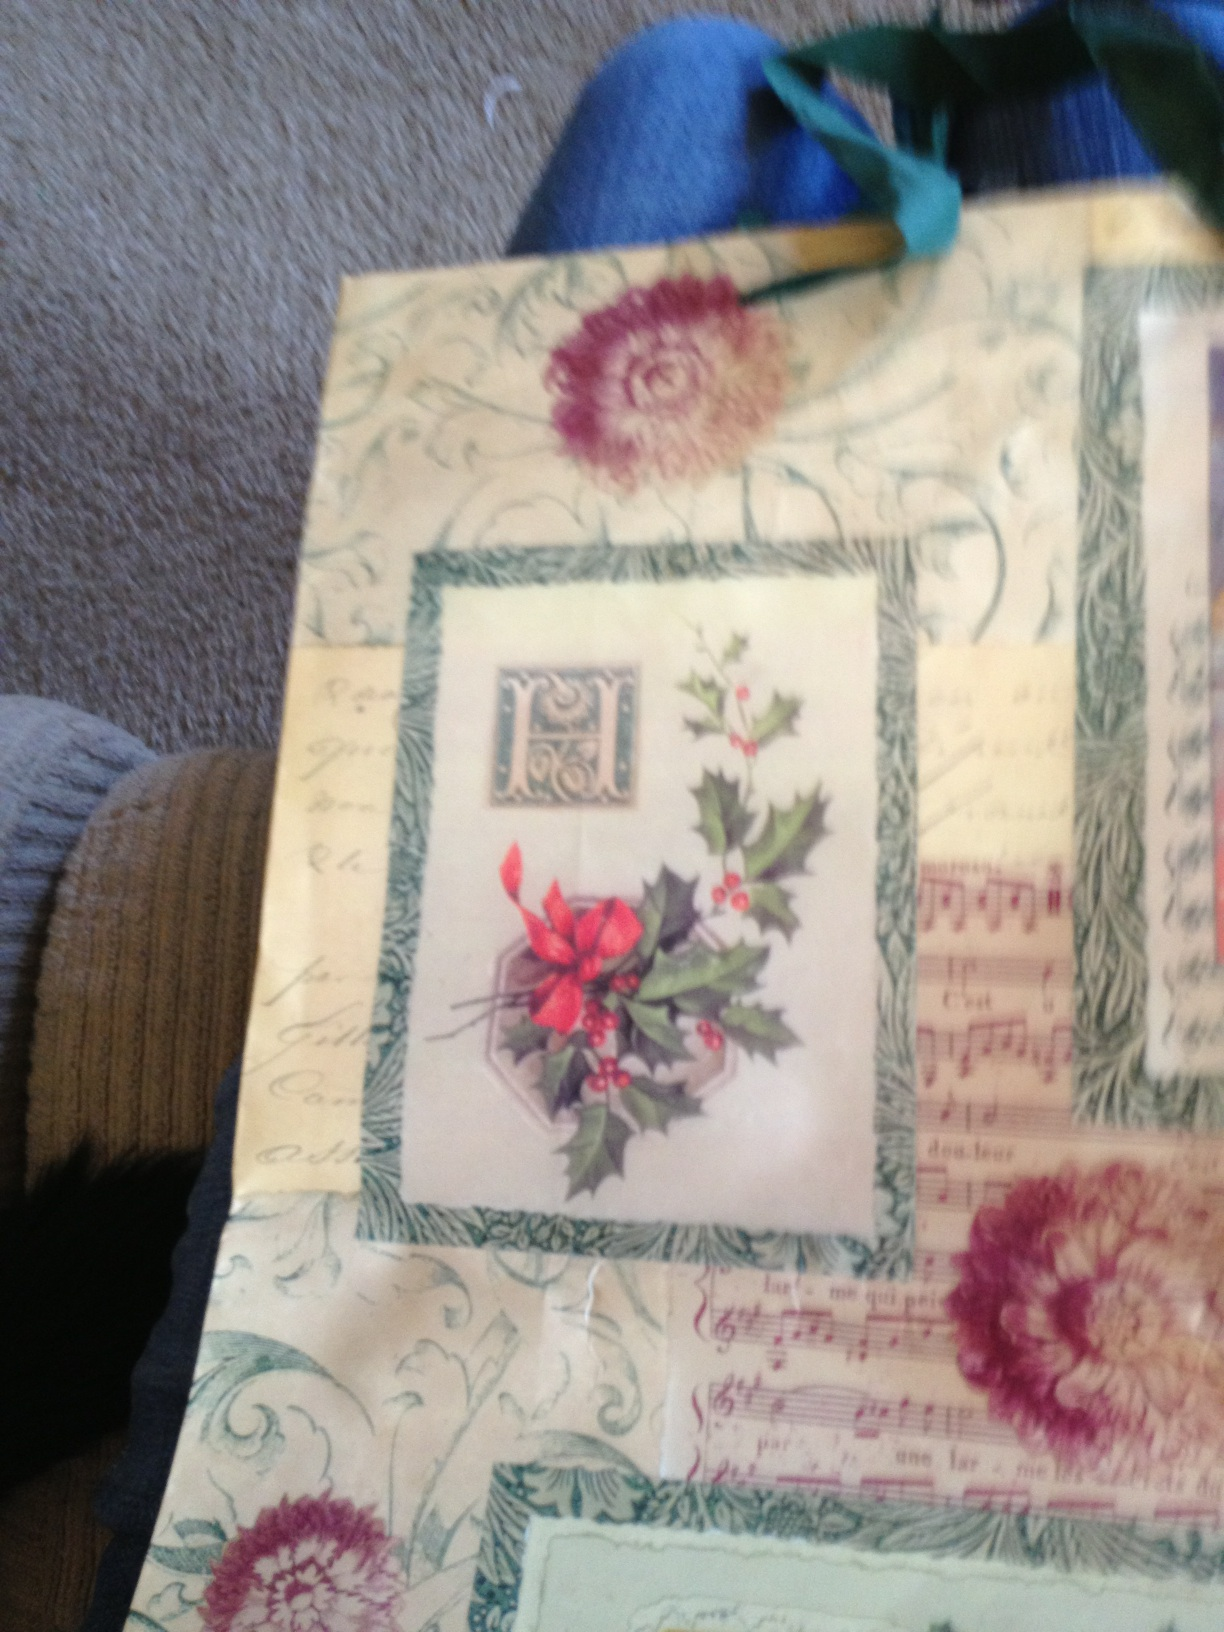What is the design on this gift bag? The design on the gift bag features vibrant holly with red berries and lush green leaves, along with an ornamental block with the letter 'H', and nostalgic sheet music among swirling patterns. It evokes a festive, vintage holiday theme. 